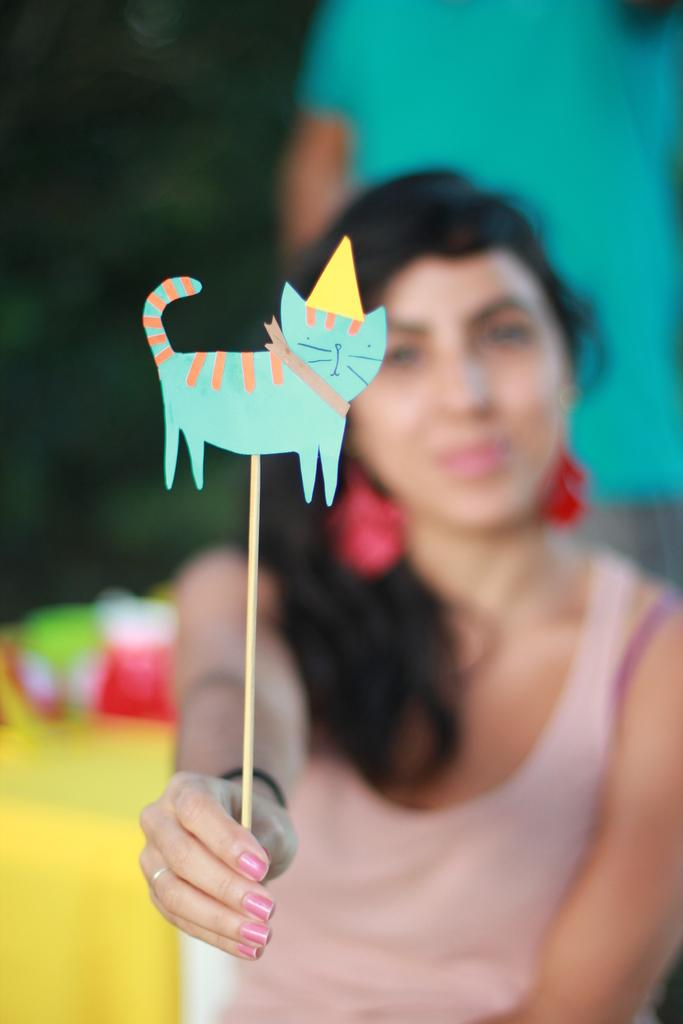Who is present in the image? There is a woman in the image. What is the woman doing in the image? The woman is holding an object in the image. Where is the object located in relation to the woman? The object is located at the bottom of the image. What type of plants can be seen growing at the party in the image? There is no party or plants present in the image; it features a woman holding an object. 